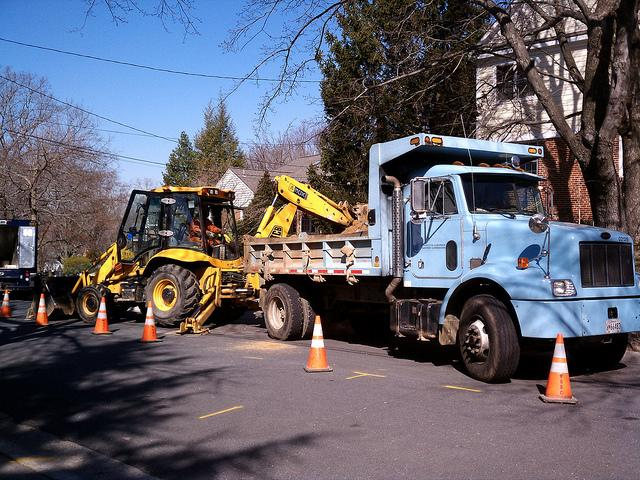What is near the blue truck?

Choices:
A) traffic cone
B) carrot
C) horse
D) stop sign traffic cone 